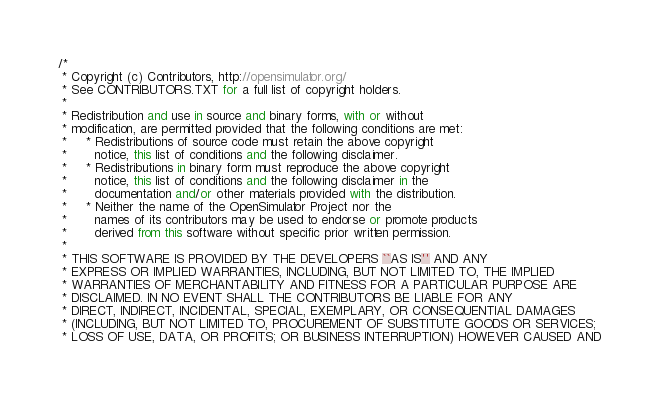Convert code to text. <code><loc_0><loc_0><loc_500><loc_500><_C#_>/*
 * Copyright (c) Contributors, http://opensimulator.org/
 * See CONTRIBUTORS.TXT for a full list of copyright holders.
 *
 * Redistribution and use in source and binary forms, with or without
 * modification, are permitted provided that the following conditions are met:
 *     * Redistributions of source code must retain the above copyright
 *       notice, this list of conditions and the following disclaimer.
 *     * Redistributions in binary form must reproduce the above copyright
 *       notice, this list of conditions and the following disclaimer in the
 *       documentation and/or other materials provided with the distribution.
 *     * Neither the name of the OpenSimulator Project nor the
 *       names of its contributors may be used to endorse or promote products
 *       derived from this software without specific prior written permission.
 *
 * THIS SOFTWARE IS PROVIDED BY THE DEVELOPERS ``AS IS'' AND ANY
 * EXPRESS OR IMPLIED WARRANTIES, INCLUDING, BUT NOT LIMITED TO, THE IMPLIED
 * WARRANTIES OF MERCHANTABILITY AND FITNESS FOR A PARTICULAR PURPOSE ARE
 * DISCLAIMED. IN NO EVENT SHALL THE CONTRIBUTORS BE LIABLE FOR ANY
 * DIRECT, INDIRECT, INCIDENTAL, SPECIAL, EXEMPLARY, OR CONSEQUENTIAL DAMAGES
 * (INCLUDING, BUT NOT LIMITED TO, PROCUREMENT OF SUBSTITUTE GOODS OR SERVICES;
 * LOSS OF USE, DATA, OR PROFITS; OR BUSINESS INTERRUPTION) HOWEVER CAUSED AND</code> 